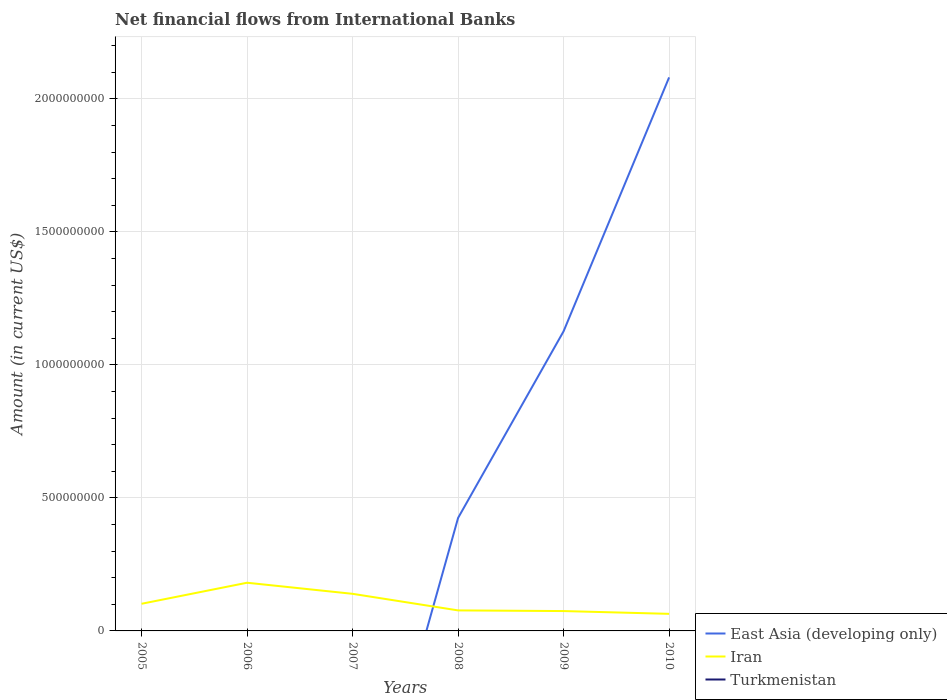How many different coloured lines are there?
Your answer should be compact. 2. Does the line corresponding to East Asia (developing only) intersect with the line corresponding to Iran?
Your response must be concise. Yes. Across all years, what is the maximum net financial aid flows in Turkmenistan?
Provide a short and direct response. 0. What is the total net financial aid flows in Iran in the graph?
Make the answer very short. 2.49e+07. What is the difference between the highest and the second highest net financial aid flows in Iran?
Make the answer very short. 1.17e+08. What is the difference between the highest and the lowest net financial aid flows in East Asia (developing only)?
Provide a short and direct response. 2. How many lines are there?
Ensure brevity in your answer.  2. How many years are there in the graph?
Provide a succinct answer. 6. What is the difference between two consecutive major ticks on the Y-axis?
Your response must be concise. 5.00e+08. Are the values on the major ticks of Y-axis written in scientific E-notation?
Your response must be concise. No. Does the graph contain any zero values?
Provide a short and direct response. Yes. Does the graph contain grids?
Offer a very short reply. Yes. Where does the legend appear in the graph?
Provide a succinct answer. Bottom right. How many legend labels are there?
Your answer should be compact. 3. How are the legend labels stacked?
Your response must be concise. Vertical. What is the title of the graph?
Your response must be concise. Net financial flows from International Banks. Does "Equatorial Guinea" appear as one of the legend labels in the graph?
Give a very brief answer. No. What is the label or title of the X-axis?
Offer a terse response. Years. What is the Amount (in current US$) of Iran in 2005?
Keep it short and to the point. 1.02e+08. What is the Amount (in current US$) of Iran in 2006?
Offer a terse response. 1.81e+08. What is the Amount (in current US$) in Turkmenistan in 2006?
Give a very brief answer. 0. What is the Amount (in current US$) in Iran in 2007?
Ensure brevity in your answer.  1.40e+08. What is the Amount (in current US$) of Turkmenistan in 2007?
Make the answer very short. 0. What is the Amount (in current US$) of East Asia (developing only) in 2008?
Provide a succinct answer. 4.25e+08. What is the Amount (in current US$) in Iran in 2008?
Offer a very short reply. 7.72e+07. What is the Amount (in current US$) in East Asia (developing only) in 2009?
Provide a short and direct response. 1.13e+09. What is the Amount (in current US$) of Iran in 2009?
Your response must be concise. 7.47e+07. What is the Amount (in current US$) of Turkmenistan in 2009?
Offer a very short reply. 0. What is the Amount (in current US$) of East Asia (developing only) in 2010?
Offer a very short reply. 2.08e+09. What is the Amount (in current US$) of Iran in 2010?
Your answer should be compact. 6.42e+07. Across all years, what is the maximum Amount (in current US$) in East Asia (developing only)?
Keep it short and to the point. 2.08e+09. Across all years, what is the maximum Amount (in current US$) in Iran?
Make the answer very short. 1.81e+08. Across all years, what is the minimum Amount (in current US$) in East Asia (developing only)?
Keep it short and to the point. 0. Across all years, what is the minimum Amount (in current US$) of Iran?
Ensure brevity in your answer.  6.42e+07. What is the total Amount (in current US$) in East Asia (developing only) in the graph?
Ensure brevity in your answer.  3.63e+09. What is the total Amount (in current US$) in Iran in the graph?
Your answer should be very brief. 6.39e+08. What is the difference between the Amount (in current US$) in Iran in 2005 and that in 2006?
Your answer should be very brief. -7.91e+07. What is the difference between the Amount (in current US$) of Iran in 2005 and that in 2007?
Offer a very short reply. -3.74e+07. What is the difference between the Amount (in current US$) of Iran in 2005 and that in 2008?
Ensure brevity in your answer.  2.49e+07. What is the difference between the Amount (in current US$) of Iran in 2005 and that in 2009?
Ensure brevity in your answer.  2.74e+07. What is the difference between the Amount (in current US$) of Iran in 2005 and that in 2010?
Provide a succinct answer. 3.79e+07. What is the difference between the Amount (in current US$) of Iran in 2006 and that in 2007?
Your answer should be very brief. 4.17e+07. What is the difference between the Amount (in current US$) of Iran in 2006 and that in 2008?
Your response must be concise. 1.04e+08. What is the difference between the Amount (in current US$) in Iran in 2006 and that in 2009?
Keep it short and to the point. 1.07e+08. What is the difference between the Amount (in current US$) of Iran in 2006 and that in 2010?
Offer a terse response. 1.17e+08. What is the difference between the Amount (in current US$) in Iran in 2007 and that in 2008?
Your answer should be very brief. 6.23e+07. What is the difference between the Amount (in current US$) in Iran in 2007 and that in 2009?
Give a very brief answer. 6.48e+07. What is the difference between the Amount (in current US$) in Iran in 2007 and that in 2010?
Your answer should be very brief. 7.53e+07. What is the difference between the Amount (in current US$) of East Asia (developing only) in 2008 and that in 2009?
Your answer should be compact. -7.02e+08. What is the difference between the Amount (in current US$) of Iran in 2008 and that in 2009?
Give a very brief answer. 2.50e+06. What is the difference between the Amount (in current US$) in East Asia (developing only) in 2008 and that in 2010?
Your response must be concise. -1.66e+09. What is the difference between the Amount (in current US$) in Iran in 2008 and that in 2010?
Keep it short and to the point. 1.30e+07. What is the difference between the Amount (in current US$) of East Asia (developing only) in 2009 and that in 2010?
Make the answer very short. -9.55e+08. What is the difference between the Amount (in current US$) of Iran in 2009 and that in 2010?
Ensure brevity in your answer.  1.05e+07. What is the difference between the Amount (in current US$) in East Asia (developing only) in 2008 and the Amount (in current US$) in Iran in 2009?
Keep it short and to the point. 3.50e+08. What is the difference between the Amount (in current US$) in East Asia (developing only) in 2008 and the Amount (in current US$) in Iran in 2010?
Make the answer very short. 3.61e+08. What is the difference between the Amount (in current US$) in East Asia (developing only) in 2009 and the Amount (in current US$) in Iran in 2010?
Offer a terse response. 1.06e+09. What is the average Amount (in current US$) of East Asia (developing only) per year?
Ensure brevity in your answer.  6.05e+08. What is the average Amount (in current US$) in Iran per year?
Keep it short and to the point. 1.06e+08. What is the average Amount (in current US$) of Turkmenistan per year?
Make the answer very short. 0. In the year 2008, what is the difference between the Amount (in current US$) in East Asia (developing only) and Amount (in current US$) in Iran?
Keep it short and to the point. 3.48e+08. In the year 2009, what is the difference between the Amount (in current US$) in East Asia (developing only) and Amount (in current US$) in Iran?
Ensure brevity in your answer.  1.05e+09. In the year 2010, what is the difference between the Amount (in current US$) in East Asia (developing only) and Amount (in current US$) in Iran?
Ensure brevity in your answer.  2.02e+09. What is the ratio of the Amount (in current US$) of Iran in 2005 to that in 2006?
Provide a succinct answer. 0.56. What is the ratio of the Amount (in current US$) of Iran in 2005 to that in 2007?
Offer a terse response. 0.73. What is the ratio of the Amount (in current US$) of Iran in 2005 to that in 2008?
Offer a very short reply. 1.32. What is the ratio of the Amount (in current US$) of Iran in 2005 to that in 2009?
Offer a very short reply. 1.37. What is the ratio of the Amount (in current US$) of Iran in 2005 to that in 2010?
Provide a succinct answer. 1.59. What is the ratio of the Amount (in current US$) of Iran in 2006 to that in 2007?
Provide a succinct answer. 1.3. What is the ratio of the Amount (in current US$) in Iran in 2006 to that in 2008?
Keep it short and to the point. 2.35. What is the ratio of the Amount (in current US$) of Iran in 2006 to that in 2009?
Make the answer very short. 2.43. What is the ratio of the Amount (in current US$) of Iran in 2006 to that in 2010?
Keep it short and to the point. 2.82. What is the ratio of the Amount (in current US$) in Iran in 2007 to that in 2008?
Offer a terse response. 1.81. What is the ratio of the Amount (in current US$) in Iran in 2007 to that in 2009?
Keep it short and to the point. 1.87. What is the ratio of the Amount (in current US$) in Iran in 2007 to that in 2010?
Offer a very short reply. 2.17. What is the ratio of the Amount (in current US$) of East Asia (developing only) in 2008 to that in 2009?
Your answer should be compact. 0.38. What is the ratio of the Amount (in current US$) of Iran in 2008 to that in 2009?
Offer a very short reply. 1.03. What is the ratio of the Amount (in current US$) in East Asia (developing only) in 2008 to that in 2010?
Your response must be concise. 0.2. What is the ratio of the Amount (in current US$) of Iran in 2008 to that in 2010?
Ensure brevity in your answer.  1.2. What is the ratio of the Amount (in current US$) of East Asia (developing only) in 2009 to that in 2010?
Keep it short and to the point. 0.54. What is the ratio of the Amount (in current US$) in Iran in 2009 to that in 2010?
Offer a very short reply. 1.16. What is the difference between the highest and the second highest Amount (in current US$) in East Asia (developing only)?
Give a very brief answer. 9.55e+08. What is the difference between the highest and the second highest Amount (in current US$) of Iran?
Ensure brevity in your answer.  4.17e+07. What is the difference between the highest and the lowest Amount (in current US$) of East Asia (developing only)?
Provide a succinct answer. 2.08e+09. What is the difference between the highest and the lowest Amount (in current US$) of Iran?
Make the answer very short. 1.17e+08. 